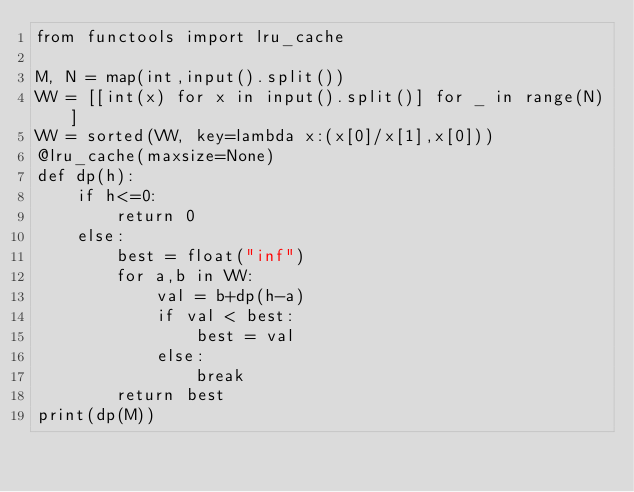<code> <loc_0><loc_0><loc_500><loc_500><_Python_>from functools import lru_cache

M, N = map(int,input().split())
VW = [[int(x) for x in input().split()] for _ in range(N)]
VW = sorted(VW, key=lambda x:(x[0]/x[1],x[0]))
@lru_cache(maxsize=None)
def dp(h):
    if h<=0:
        return 0
    else:
        best = float("inf")
        for a,b in VW:
            val = b+dp(h-a)
            if val < best:
                best = val
            else:
                break
        return best
print(dp(M))
</code> 